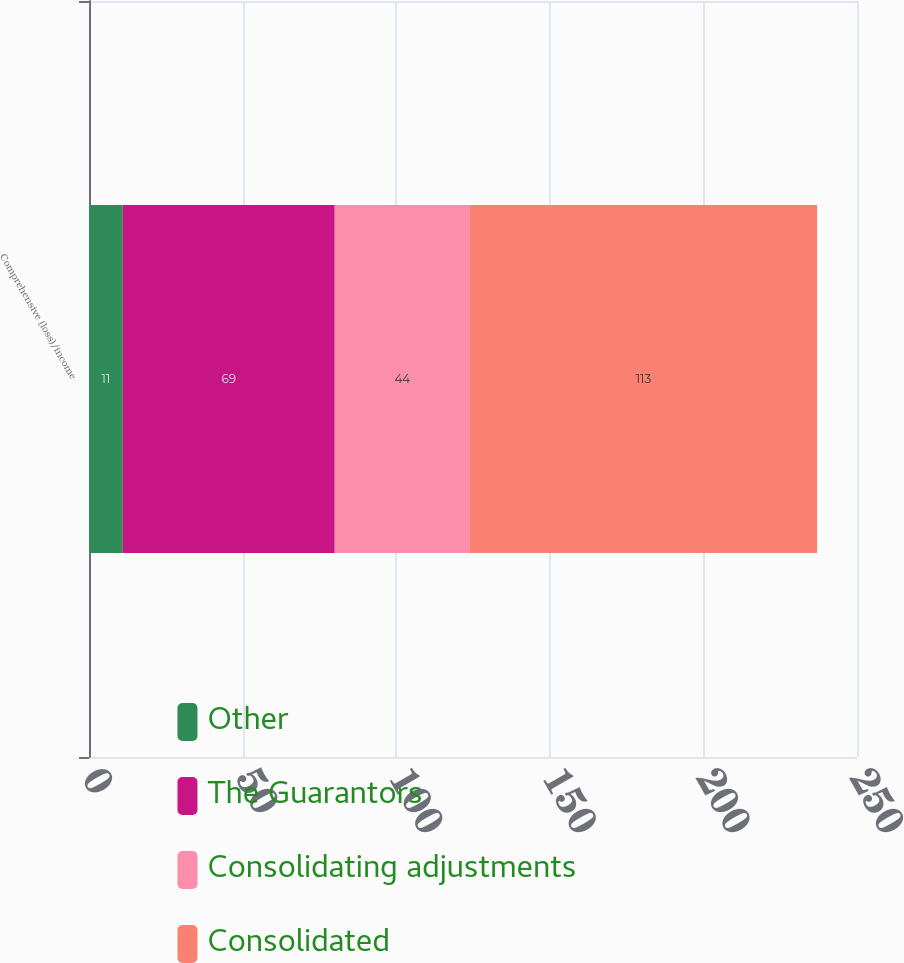Convert chart. <chart><loc_0><loc_0><loc_500><loc_500><stacked_bar_chart><ecel><fcel>Comprehensive (loss)/income<nl><fcel>Other<fcel>11<nl><fcel>The Guarantors<fcel>69<nl><fcel>Consolidating adjustments<fcel>44<nl><fcel>Consolidated<fcel>113<nl></chart> 